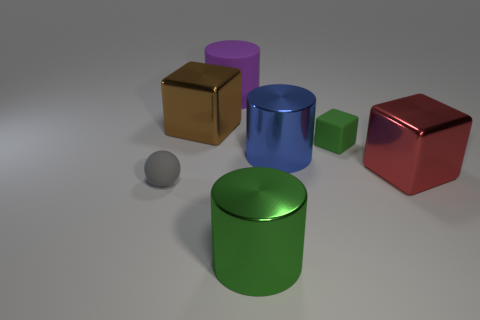What is the large thing that is both left of the green metallic cylinder and in front of the big purple thing made of?
Keep it short and to the point. Metal. How many blue shiny objects have the same shape as the green rubber thing?
Your answer should be very brief. 0. There is a matte object that is on the right side of the blue thing to the right of the large brown metallic thing; how big is it?
Provide a short and direct response. Small. There is a small thing that is behind the large blue metal object; is it the same color as the big thing in front of the tiny gray ball?
Give a very brief answer. Yes. How many tiny gray matte things are to the right of the shiny block that is on the right side of the green shiny cylinder left of the big red metallic cube?
Your answer should be very brief. 0. How many objects are in front of the big blue shiny object and on the left side of the large red block?
Keep it short and to the point. 2. Are there more blue cylinders that are left of the large purple cylinder than large blue cylinders?
Offer a terse response. No. How many brown blocks are the same size as the brown metal thing?
Offer a very short reply. 0. What number of big things are gray things or green rubber things?
Offer a terse response. 0. What number of small brown blocks are there?
Give a very brief answer. 0. 